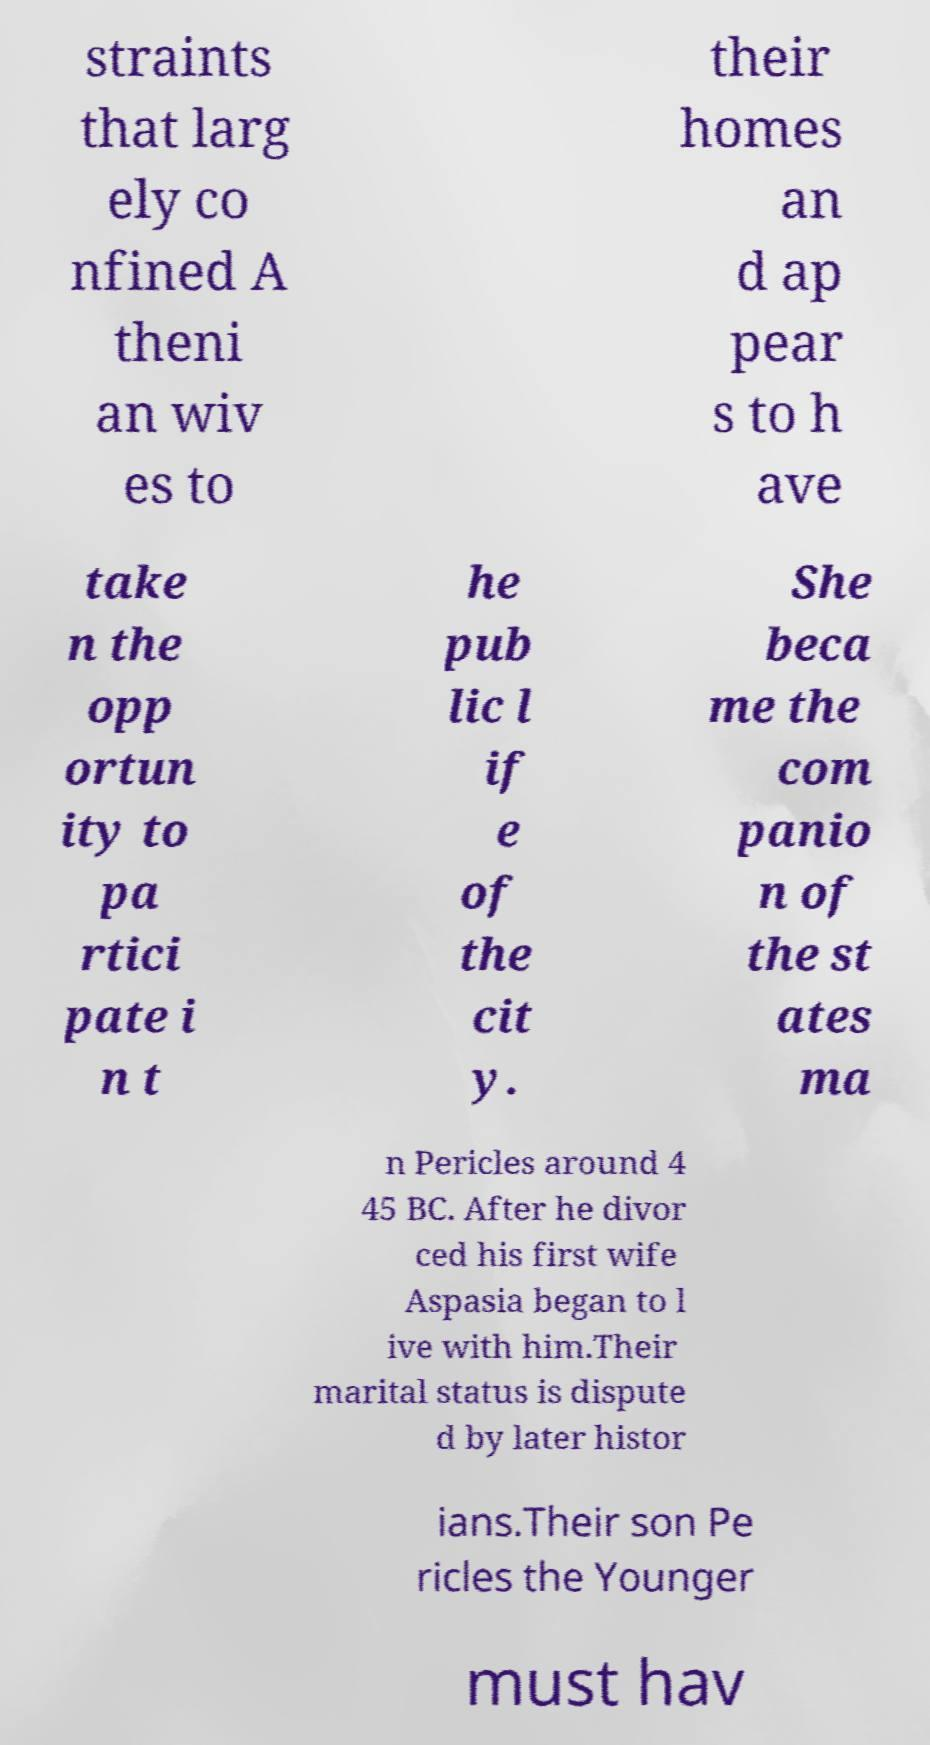For documentation purposes, I need the text within this image transcribed. Could you provide that? straints that larg ely co nfined A theni an wiv es to their homes an d ap pear s to h ave take n the opp ortun ity to pa rtici pate i n t he pub lic l if e of the cit y. She beca me the com panio n of the st ates ma n Pericles around 4 45 BC. After he divor ced his first wife Aspasia began to l ive with him.Their marital status is dispute d by later histor ians.Their son Pe ricles the Younger must hav 